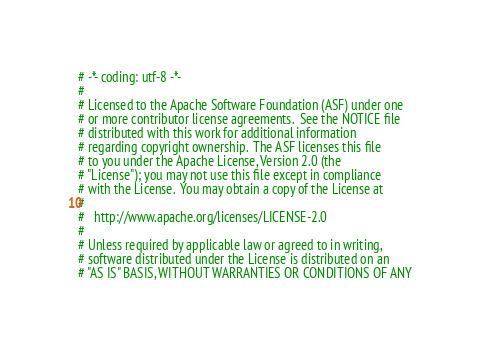<code> <loc_0><loc_0><loc_500><loc_500><_Python_># -*- coding: utf-8 -*-
#
# Licensed to the Apache Software Foundation (ASF) under one
# or more contributor license agreements.  See the NOTICE file
# distributed with this work for additional information
# regarding copyright ownership.  The ASF licenses this file
# to you under the Apache License, Version 2.0 (the
# "License"); you may not use this file except in compliance
# with the License.  You may obtain a copy of the License at
#
#   http://www.apache.org/licenses/LICENSE-2.0
#
# Unless required by applicable law or agreed to in writing,
# software distributed under the License is distributed on an
# "AS IS" BASIS, WITHOUT WARRANTIES OR CONDITIONS OF ANY</code> 